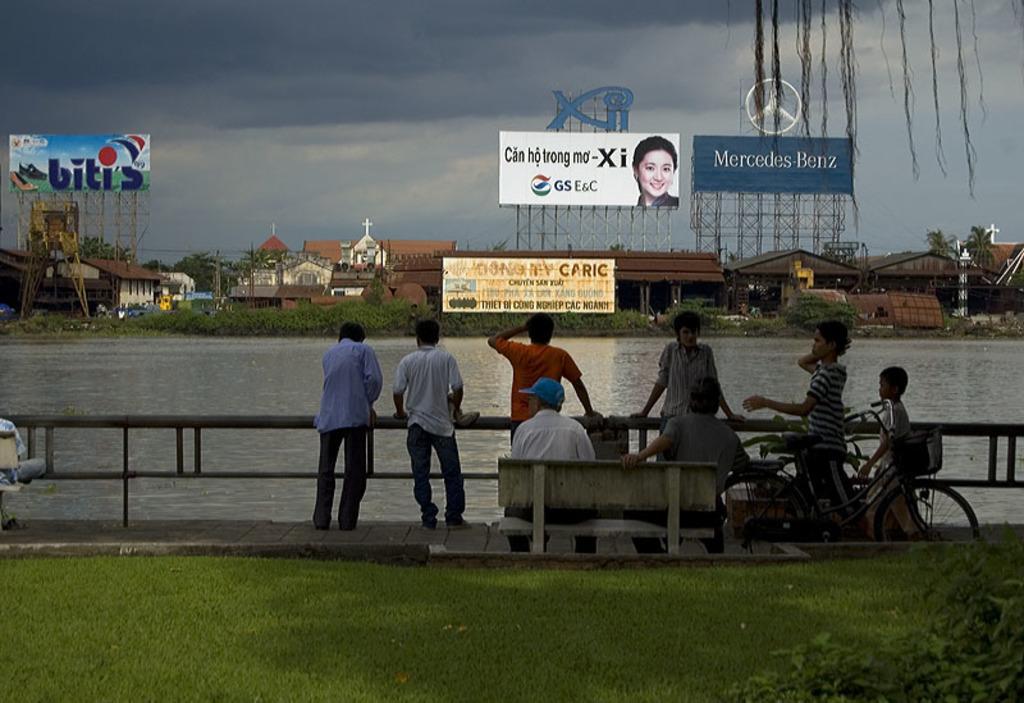How would you summarize this image in a sentence or two? In this picture we can see a group of people some are sitting on bench and some are standing at fence and in front we can see grass, bicycle and in background we can see water, houses, hoarding, sky with windows. 